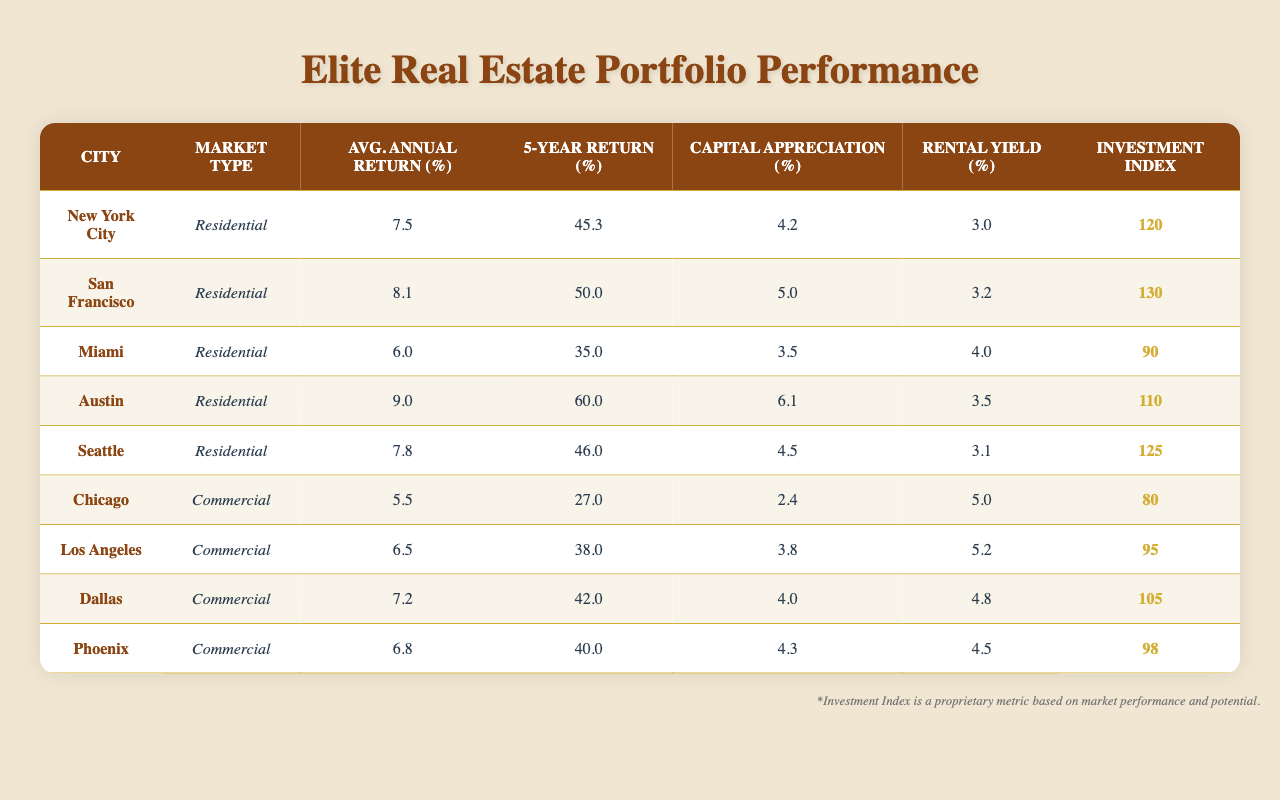What city has the highest average annual return? By looking at the average annual return column, we see that Austin has an average annual return of 9.0%, which is higher than all other cities listed.
Answer: Austin What is the investment index of San Francisco? San Francisco’s investment index is directly listed in the table, which is 130.
Answer: 130 Which city has the lowest rental yield? By examining the rental yield column, Miami displays the lowest yield value of 4.0% compared to the other cities.
Answer: Miami What is the difference between the 5-year return of New York City and Dallas? The 5-year return for New York City is 45.3% and for Dallas is 42.0%. To find the difference, we subtract Dallas’ return from New York City’s: 45.3% - 42.0% = 3.3%.
Answer: 3.3% Is the average annual return for residential properties generally higher than for commercial properties? From the average annual return of residential properties (7.5, 8.1, 6.0, 9.0, 7.8) and commercial properties (5.5, 6.5, 7.2, 6.8), we can calculate the averages: Residential average is 7.48% and Commercial average is 6.25%. This shows that residential properties have a higher average annual return.
Answer: Yes Which city experienced the highest capital appreciation? The highest capital appreciation can be found by scanning the table for the capital appreciation values. Austin shows the highest at 6.1%.
Answer: Austin Calculate the average rental yield for all the cities listed. The rental yields are 3.0%, 3.2%, 4.0%, 3.5%, 3.1%, 5.0%, 5.2%, 4.8%, and 4.5%. Summing them gives 3.0 + 3.2 + 4.0 + 3.5 + 3.1 + 5.0 + 5.2 + 4.8 + 4.5 = 36.3%. We then divide by the number of cities (9) to find the average: 36.3% / 9 = 4.03%.
Answer: 4.03% Does Miami provide a better 5-year return compared to Chicago? Miami’s 5-year return is 35.0%, while Chicago’s is 27.0%. Therefore, Miami does provide a better return than Chicago.
Answer: Yes Which city has a higher rental yield: Dallas or Seattle? The rental yield for Dallas is 4.8% and for Seattle is 3.1%. Comparing these figures shows that Dallas has a higher rental yield than Seattle.
Answer: Dallas 